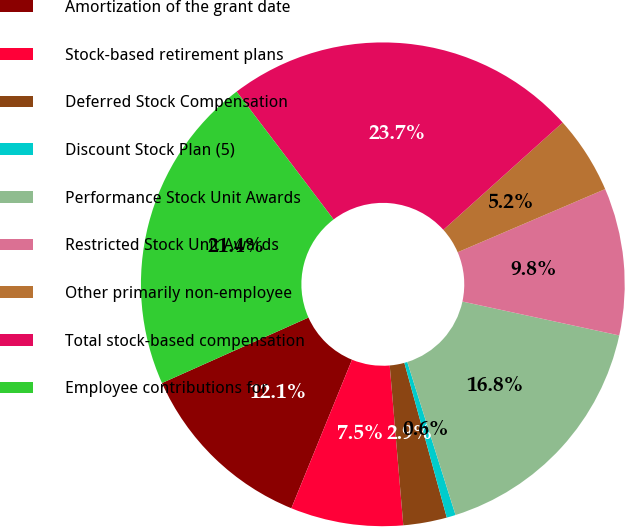Convert chart. <chart><loc_0><loc_0><loc_500><loc_500><pie_chart><fcel>Amortization of the grant date<fcel>Stock-based retirement plans<fcel>Deferred Stock Compensation<fcel>Discount Stock Plan (5)<fcel>Performance Stock Unit Awards<fcel>Restricted Stock Unit Awards<fcel>Other primarily non-employee<fcel>Total stock-based compensation<fcel>Employee contributions for<nl><fcel>12.14%<fcel>7.52%<fcel>2.91%<fcel>0.6%<fcel>16.75%<fcel>9.83%<fcel>5.22%<fcel>23.67%<fcel>21.36%<nl></chart> 